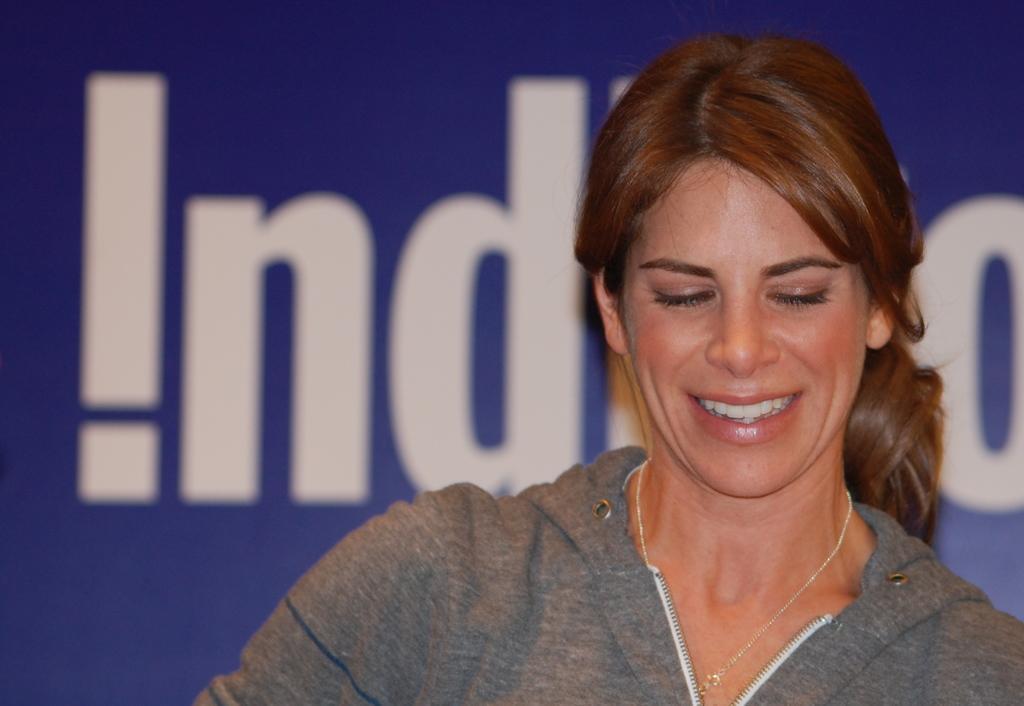Can you describe this image briefly? In this image we can see a woman with brown hair is wearing a grey jacket. 